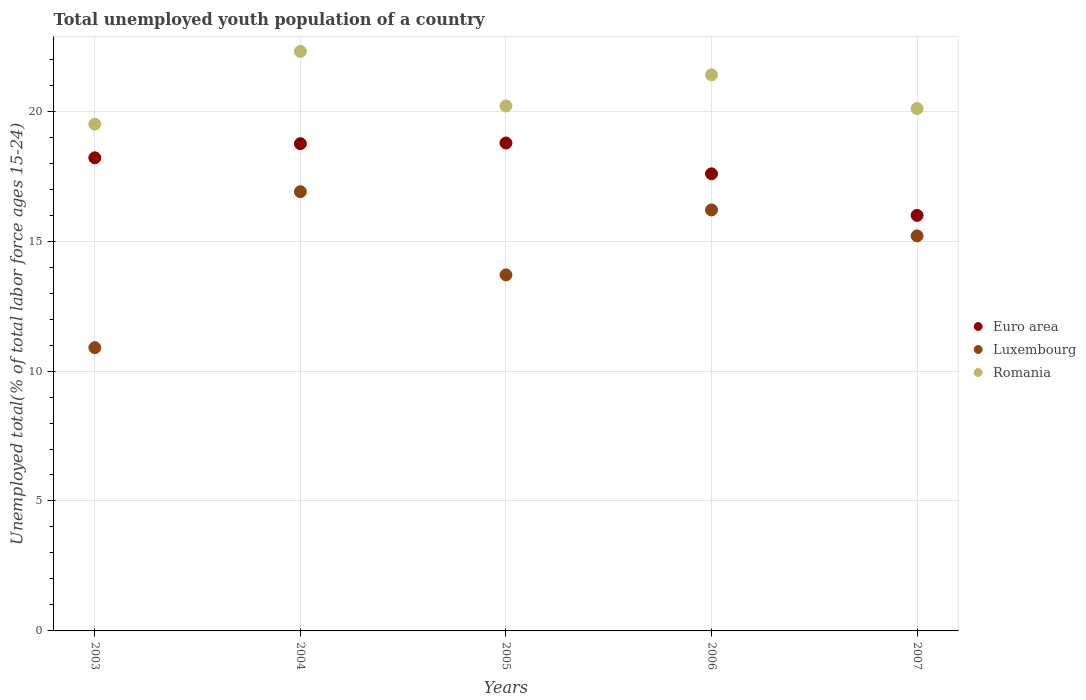What is the percentage of total unemployed youth population of a country in Luxembourg in 2005?
Keep it short and to the point. 13.7. Across all years, what is the maximum percentage of total unemployed youth population of a country in Romania?
Provide a succinct answer. 22.3. In which year was the percentage of total unemployed youth population of a country in Romania maximum?
Offer a terse response. 2004. What is the total percentage of total unemployed youth population of a country in Luxembourg in the graph?
Provide a short and direct response. 72.9. What is the difference between the percentage of total unemployed youth population of a country in Euro area in 2004 and that in 2006?
Your answer should be very brief. 1.16. What is the difference between the percentage of total unemployed youth population of a country in Euro area in 2003 and the percentage of total unemployed youth population of a country in Luxembourg in 2007?
Ensure brevity in your answer.  3. What is the average percentage of total unemployed youth population of a country in Luxembourg per year?
Ensure brevity in your answer.  14.58. In the year 2007, what is the difference between the percentage of total unemployed youth population of a country in Romania and percentage of total unemployed youth population of a country in Euro area?
Provide a succinct answer. 4.11. In how many years, is the percentage of total unemployed youth population of a country in Luxembourg greater than 20 %?
Offer a very short reply. 0. What is the ratio of the percentage of total unemployed youth population of a country in Romania in 2004 to that in 2006?
Your answer should be compact. 1.04. What is the difference between the highest and the second highest percentage of total unemployed youth population of a country in Euro area?
Ensure brevity in your answer.  0.03. What is the difference between the highest and the lowest percentage of total unemployed youth population of a country in Romania?
Your response must be concise. 2.8. In how many years, is the percentage of total unemployed youth population of a country in Romania greater than the average percentage of total unemployed youth population of a country in Romania taken over all years?
Your answer should be compact. 2. Does the percentage of total unemployed youth population of a country in Luxembourg monotonically increase over the years?
Offer a terse response. No. Is the percentage of total unemployed youth population of a country in Romania strictly greater than the percentage of total unemployed youth population of a country in Euro area over the years?
Ensure brevity in your answer.  Yes. How many dotlines are there?
Offer a terse response. 3. How many years are there in the graph?
Keep it short and to the point. 5. Are the values on the major ticks of Y-axis written in scientific E-notation?
Offer a terse response. No. Where does the legend appear in the graph?
Your answer should be very brief. Center right. How are the legend labels stacked?
Provide a short and direct response. Vertical. What is the title of the graph?
Your answer should be compact. Total unemployed youth population of a country. Does "Montenegro" appear as one of the legend labels in the graph?
Offer a terse response. No. What is the label or title of the Y-axis?
Keep it short and to the point. Unemployed total(% of total labor force ages 15-24). What is the Unemployed total(% of total labor force ages 15-24) of Euro area in 2003?
Your answer should be compact. 18.2. What is the Unemployed total(% of total labor force ages 15-24) in Luxembourg in 2003?
Your answer should be very brief. 10.9. What is the Unemployed total(% of total labor force ages 15-24) of Euro area in 2004?
Provide a succinct answer. 18.75. What is the Unemployed total(% of total labor force ages 15-24) in Luxembourg in 2004?
Your answer should be compact. 16.9. What is the Unemployed total(% of total labor force ages 15-24) of Romania in 2004?
Ensure brevity in your answer.  22.3. What is the Unemployed total(% of total labor force ages 15-24) of Euro area in 2005?
Offer a very short reply. 18.77. What is the Unemployed total(% of total labor force ages 15-24) in Luxembourg in 2005?
Keep it short and to the point. 13.7. What is the Unemployed total(% of total labor force ages 15-24) of Romania in 2005?
Your answer should be compact. 20.2. What is the Unemployed total(% of total labor force ages 15-24) in Euro area in 2006?
Offer a very short reply. 17.59. What is the Unemployed total(% of total labor force ages 15-24) in Luxembourg in 2006?
Offer a very short reply. 16.2. What is the Unemployed total(% of total labor force ages 15-24) of Romania in 2006?
Make the answer very short. 21.4. What is the Unemployed total(% of total labor force ages 15-24) in Euro area in 2007?
Offer a terse response. 15.99. What is the Unemployed total(% of total labor force ages 15-24) of Luxembourg in 2007?
Offer a terse response. 15.2. What is the Unemployed total(% of total labor force ages 15-24) of Romania in 2007?
Offer a terse response. 20.1. Across all years, what is the maximum Unemployed total(% of total labor force ages 15-24) in Euro area?
Keep it short and to the point. 18.77. Across all years, what is the maximum Unemployed total(% of total labor force ages 15-24) in Luxembourg?
Your answer should be compact. 16.9. Across all years, what is the maximum Unemployed total(% of total labor force ages 15-24) in Romania?
Keep it short and to the point. 22.3. Across all years, what is the minimum Unemployed total(% of total labor force ages 15-24) in Euro area?
Your response must be concise. 15.99. Across all years, what is the minimum Unemployed total(% of total labor force ages 15-24) of Luxembourg?
Keep it short and to the point. 10.9. Across all years, what is the minimum Unemployed total(% of total labor force ages 15-24) of Romania?
Your answer should be very brief. 19.5. What is the total Unemployed total(% of total labor force ages 15-24) of Euro area in the graph?
Your answer should be very brief. 89.31. What is the total Unemployed total(% of total labor force ages 15-24) in Luxembourg in the graph?
Ensure brevity in your answer.  72.9. What is the total Unemployed total(% of total labor force ages 15-24) of Romania in the graph?
Offer a terse response. 103.5. What is the difference between the Unemployed total(% of total labor force ages 15-24) in Euro area in 2003 and that in 2004?
Offer a very short reply. -0.54. What is the difference between the Unemployed total(% of total labor force ages 15-24) of Luxembourg in 2003 and that in 2004?
Provide a succinct answer. -6. What is the difference between the Unemployed total(% of total labor force ages 15-24) in Euro area in 2003 and that in 2005?
Your response must be concise. -0.57. What is the difference between the Unemployed total(% of total labor force ages 15-24) in Luxembourg in 2003 and that in 2005?
Keep it short and to the point. -2.8. What is the difference between the Unemployed total(% of total labor force ages 15-24) in Romania in 2003 and that in 2005?
Provide a short and direct response. -0.7. What is the difference between the Unemployed total(% of total labor force ages 15-24) in Euro area in 2003 and that in 2006?
Offer a very short reply. 0.62. What is the difference between the Unemployed total(% of total labor force ages 15-24) in Luxembourg in 2003 and that in 2006?
Make the answer very short. -5.3. What is the difference between the Unemployed total(% of total labor force ages 15-24) of Euro area in 2003 and that in 2007?
Your answer should be compact. 2.22. What is the difference between the Unemployed total(% of total labor force ages 15-24) in Luxembourg in 2003 and that in 2007?
Your answer should be compact. -4.3. What is the difference between the Unemployed total(% of total labor force ages 15-24) of Euro area in 2004 and that in 2005?
Your response must be concise. -0.03. What is the difference between the Unemployed total(% of total labor force ages 15-24) of Euro area in 2004 and that in 2006?
Provide a short and direct response. 1.16. What is the difference between the Unemployed total(% of total labor force ages 15-24) in Luxembourg in 2004 and that in 2006?
Your response must be concise. 0.7. What is the difference between the Unemployed total(% of total labor force ages 15-24) in Romania in 2004 and that in 2006?
Your answer should be compact. 0.9. What is the difference between the Unemployed total(% of total labor force ages 15-24) in Euro area in 2004 and that in 2007?
Your answer should be compact. 2.76. What is the difference between the Unemployed total(% of total labor force ages 15-24) of Romania in 2004 and that in 2007?
Give a very brief answer. 2.2. What is the difference between the Unemployed total(% of total labor force ages 15-24) in Euro area in 2005 and that in 2006?
Your answer should be compact. 1.19. What is the difference between the Unemployed total(% of total labor force ages 15-24) in Romania in 2005 and that in 2006?
Give a very brief answer. -1.2. What is the difference between the Unemployed total(% of total labor force ages 15-24) of Euro area in 2005 and that in 2007?
Keep it short and to the point. 2.79. What is the difference between the Unemployed total(% of total labor force ages 15-24) in Luxembourg in 2005 and that in 2007?
Offer a terse response. -1.5. What is the difference between the Unemployed total(% of total labor force ages 15-24) in Euro area in 2006 and that in 2007?
Offer a terse response. 1.6. What is the difference between the Unemployed total(% of total labor force ages 15-24) of Luxembourg in 2006 and that in 2007?
Your answer should be very brief. 1. What is the difference between the Unemployed total(% of total labor force ages 15-24) in Romania in 2006 and that in 2007?
Make the answer very short. 1.3. What is the difference between the Unemployed total(% of total labor force ages 15-24) in Euro area in 2003 and the Unemployed total(% of total labor force ages 15-24) in Luxembourg in 2004?
Ensure brevity in your answer.  1.3. What is the difference between the Unemployed total(% of total labor force ages 15-24) in Euro area in 2003 and the Unemployed total(% of total labor force ages 15-24) in Romania in 2004?
Ensure brevity in your answer.  -4.09. What is the difference between the Unemployed total(% of total labor force ages 15-24) in Luxembourg in 2003 and the Unemployed total(% of total labor force ages 15-24) in Romania in 2004?
Provide a short and direct response. -11.4. What is the difference between the Unemployed total(% of total labor force ages 15-24) of Euro area in 2003 and the Unemployed total(% of total labor force ages 15-24) of Luxembourg in 2005?
Give a very brief answer. 4.5. What is the difference between the Unemployed total(% of total labor force ages 15-24) in Euro area in 2003 and the Unemployed total(% of total labor force ages 15-24) in Romania in 2005?
Give a very brief answer. -2. What is the difference between the Unemployed total(% of total labor force ages 15-24) in Luxembourg in 2003 and the Unemployed total(% of total labor force ages 15-24) in Romania in 2005?
Give a very brief answer. -9.3. What is the difference between the Unemployed total(% of total labor force ages 15-24) of Euro area in 2003 and the Unemployed total(% of total labor force ages 15-24) of Luxembourg in 2006?
Your response must be concise. 2. What is the difference between the Unemployed total(% of total labor force ages 15-24) of Euro area in 2003 and the Unemployed total(% of total labor force ages 15-24) of Romania in 2006?
Provide a short and direct response. -3.19. What is the difference between the Unemployed total(% of total labor force ages 15-24) in Luxembourg in 2003 and the Unemployed total(% of total labor force ages 15-24) in Romania in 2006?
Ensure brevity in your answer.  -10.5. What is the difference between the Unemployed total(% of total labor force ages 15-24) of Euro area in 2003 and the Unemployed total(% of total labor force ages 15-24) of Luxembourg in 2007?
Keep it short and to the point. 3. What is the difference between the Unemployed total(% of total labor force ages 15-24) in Euro area in 2003 and the Unemployed total(% of total labor force ages 15-24) in Romania in 2007?
Offer a terse response. -1.9. What is the difference between the Unemployed total(% of total labor force ages 15-24) of Luxembourg in 2003 and the Unemployed total(% of total labor force ages 15-24) of Romania in 2007?
Offer a very short reply. -9.2. What is the difference between the Unemployed total(% of total labor force ages 15-24) in Euro area in 2004 and the Unemployed total(% of total labor force ages 15-24) in Luxembourg in 2005?
Give a very brief answer. 5.05. What is the difference between the Unemployed total(% of total labor force ages 15-24) in Euro area in 2004 and the Unemployed total(% of total labor force ages 15-24) in Romania in 2005?
Offer a terse response. -1.45. What is the difference between the Unemployed total(% of total labor force ages 15-24) in Euro area in 2004 and the Unemployed total(% of total labor force ages 15-24) in Luxembourg in 2006?
Keep it short and to the point. 2.55. What is the difference between the Unemployed total(% of total labor force ages 15-24) of Euro area in 2004 and the Unemployed total(% of total labor force ages 15-24) of Romania in 2006?
Make the answer very short. -2.65. What is the difference between the Unemployed total(% of total labor force ages 15-24) of Luxembourg in 2004 and the Unemployed total(% of total labor force ages 15-24) of Romania in 2006?
Your response must be concise. -4.5. What is the difference between the Unemployed total(% of total labor force ages 15-24) in Euro area in 2004 and the Unemployed total(% of total labor force ages 15-24) in Luxembourg in 2007?
Offer a terse response. 3.55. What is the difference between the Unemployed total(% of total labor force ages 15-24) of Euro area in 2004 and the Unemployed total(% of total labor force ages 15-24) of Romania in 2007?
Offer a terse response. -1.35. What is the difference between the Unemployed total(% of total labor force ages 15-24) of Euro area in 2005 and the Unemployed total(% of total labor force ages 15-24) of Luxembourg in 2006?
Provide a short and direct response. 2.58. What is the difference between the Unemployed total(% of total labor force ages 15-24) of Euro area in 2005 and the Unemployed total(% of total labor force ages 15-24) of Romania in 2006?
Ensure brevity in your answer.  -2.62. What is the difference between the Unemployed total(% of total labor force ages 15-24) in Luxembourg in 2005 and the Unemployed total(% of total labor force ages 15-24) in Romania in 2006?
Your response must be concise. -7.7. What is the difference between the Unemployed total(% of total labor force ages 15-24) in Euro area in 2005 and the Unemployed total(% of total labor force ages 15-24) in Luxembourg in 2007?
Provide a short and direct response. 3.58. What is the difference between the Unemployed total(% of total labor force ages 15-24) of Euro area in 2005 and the Unemployed total(% of total labor force ages 15-24) of Romania in 2007?
Your answer should be very brief. -1.32. What is the difference between the Unemployed total(% of total labor force ages 15-24) of Luxembourg in 2005 and the Unemployed total(% of total labor force ages 15-24) of Romania in 2007?
Offer a very short reply. -6.4. What is the difference between the Unemployed total(% of total labor force ages 15-24) of Euro area in 2006 and the Unemployed total(% of total labor force ages 15-24) of Luxembourg in 2007?
Your answer should be compact. 2.39. What is the difference between the Unemployed total(% of total labor force ages 15-24) of Euro area in 2006 and the Unemployed total(% of total labor force ages 15-24) of Romania in 2007?
Give a very brief answer. -2.51. What is the average Unemployed total(% of total labor force ages 15-24) of Euro area per year?
Ensure brevity in your answer.  17.86. What is the average Unemployed total(% of total labor force ages 15-24) in Luxembourg per year?
Provide a succinct answer. 14.58. What is the average Unemployed total(% of total labor force ages 15-24) of Romania per year?
Give a very brief answer. 20.7. In the year 2003, what is the difference between the Unemployed total(% of total labor force ages 15-24) of Euro area and Unemployed total(% of total labor force ages 15-24) of Luxembourg?
Provide a succinct answer. 7.3. In the year 2003, what is the difference between the Unemployed total(% of total labor force ages 15-24) in Euro area and Unemployed total(% of total labor force ages 15-24) in Romania?
Ensure brevity in your answer.  -1.29. In the year 2003, what is the difference between the Unemployed total(% of total labor force ages 15-24) in Luxembourg and Unemployed total(% of total labor force ages 15-24) in Romania?
Your answer should be compact. -8.6. In the year 2004, what is the difference between the Unemployed total(% of total labor force ages 15-24) in Euro area and Unemployed total(% of total labor force ages 15-24) in Luxembourg?
Give a very brief answer. 1.85. In the year 2004, what is the difference between the Unemployed total(% of total labor force ages 15-24) in Euro area and Unemployed total(% of total labor force ages 15-24) in Romania?
Give a very brief answer. -3.55. In the year 2005, what is the difference between the Unemployed total(% of total labor force ages 15-24) of Euro area and Unemployed total(% of total labor force ages 15-24) of Luxembourg?
Provide a succinct answer. 5.08. In the year 2005, what is the difference between the Unemployed total(% of total labor force ages 15-24) in Euro area and Unemployed total(% of total labor force ages 15-24) in Romania?
Give a very brief answer. -1.43. In the year 2005, what is the difference between the Unemployed total(% of total labor force ages 15-24) in Luxembourg and Unemployed total(% of total labor force ages 15-24) in Romania?
Keep it short and to the point. -6.5. In the year 2006, what is the difference between the Unemployed total(% of total labor force ages 15-24) in Euro area and Unemployed total(% of total labor force ages 15-24) in Luxembourg?
Your response must be concise. 1.39. In the year 2006, what is the difference between the Unemployed total(% of total labor force ages 15-24) in Euro area and Unemployed total(% of total labor force ages 15-24) in Romania?
Provide a short and direct response. -3.81. In the year 2007, what is the difference between the Unemployed total(% of total labor force ages 15-24) in Euro area and Unemployed total(% of total labor force ages 15-24) in Luxembourg?
Give a very brief answer. 0.79. In the year 2007, what is the difference between the Unemployed total(% of total labor force ages 15-24) in Euro area and Unemployed total(% of total labor force ages 15-24) in Romania?
Make the answer very short. -4.11. What is the ratio of the Unemployed total(% of total labor force ages 15-24) in Luxembourg in 2003 to that in 2004?
Keep it short and to the point. 0.65. What is the ratio of the Unemployed total(% of total labor force ages 15-24) in Romania in 2003 to that in 2004?
Provide a short and direct response. 0.87. What is the ratio of the Unemployed total(% of total labor force ages 15-24) in Euro area in 2003 to that in 2005?
Keep it short and to the point. 0.97. What is the ratio of the Unemployed total(% of total labor force ages 15-24) in Luxembourg in 2003 to that in 2005?
Your answer should be very brief. 0.8. What is the ratio of the Unemployed total(% of total labor force ages 15-24) in Romania in 2003 to that in 2005?
Your answer should be compact. 0.97. What is the ratio of the Unemployed total(% of total labor force ages 15-24) of Euro area in 2003 to that in 2006?
Make the answer very short. 1.03. What is the ratio of the Unemployed total(% of total labor force ages 15-24) of Luxembourg in 2003 to that in 2006?
Give a very brief answer. 0.67. What is the ratio of the Unemployed total(% of total labor force ages 15-24) of Romania in 2003 to that in 2006?
Your answer should be compact. 0.91. What is the ratio of the Unemployed total(% of total labor force ages 15-24) in Euro area in 2003 to that in 2007?
Give a very brief answer. 1.14. What is the ratio of the Unemployed total(% of total labor force ages 15-24) of Luxembourg in 2003 to that in 2007?
Make the answer very short. 0.72. What is the ratio of the Unemployed total(% of total labor force ages 15-24) of Romania in 2003 to that in 2007?
Offer a terse response. 0.97. What is the ratio of the Unemployed total(% of total labor force ages 15-24) in Luxembourg in 2004 to that in 2005?
Provide a short and direct response. 1.23. What is the ratio of the Unemployed total(% of total labor force ages 15-24) in Romania in 2004 to that in 2005?
Keep it short and to the point. 1.1. What is the ratio of the Unemployed total(% of total labor force ages 15-24) in Euro area in 2004 to that in 2006?
Offer a terse response. 1.07. What is the ratio of the Unemployed total(% of total labor force ages 15-24) in Luxembourg in 2004 to that in 2006?
Keep it short and to the point. 1.04. What is the ratio of the Unemployed total(% of total labor force ages 15-24) in Romania in 2004 to that in 2006?
Give a very brief answer. 1.04. What is the ratio of the Unemployed total(% of total labor force ages 15-24) of Euro area in 2004 to that in 2007?
Your response must be concise. 1.17. What is the ratio of the Unemployed total(% of total labor force ages 15-24) of Luxembourg in 2004 to that in 2007?
Provide a short and direct response. 1.11. What is the ratio of the Unemployed total(% of total labor force ages 15-24) of Romania in 2004 to that in 2007?
Your answer should be very brief. 1.11. What is the ratio of the Unemployed total(% of total labor force ages 15-24) in Euro area in 2005 to that in 2006?
Your answer should be very brief. 1.07. What is the ratio of the Unemployed total(% of total labor force ages 15-24) of Luxembourg in 2005 to that in 2006?
Provide a succinct answer. 0.85. What is the ratio of the Unemployed total(% of total labor force ages 15-24) in Romania in 2005 to that in 2006?
Your answer should be compact. 0.94. What is the ratio of the Unemployed total(% of total labor force ages 15-24) in Euro area in 2005 to that in 2007?
Give a very brief answer. 1.17. What is the ratio of the Unemployed total(% of total labor force ages 15-24) in Luxembourg in 2005 to that in 2007?
Ensure brevity in your answer.  0.9. What is the ratio of the Unemployed total(% of total labor force ages 15-24) of Romania in 2005 to that in 2007?
Your answer should be compact. 1. What is the ratio of the Unemployed total(% of total labor force ages 15-24) of Euro area in 2006 to that in 2007?
Ensure brevity in your answer.  1.1. What is the ratio of the Unemployed total(% of total labor force ages 15-24) in Luxembourg in 2006 to that in 2007?
Your answer should be compact. 1.07. What is the ratio of the Unemployed total(% of total labor force ages 15-24) of Romania in 2006 to that in 2007?
Your response must be concise. 1.06. What is the difference between the highest and the second highest Unemployed total(% of total labor force ages 15-24) of Euro area?
Your answer should be very brief. 0.03. What is the difference between the highest and the second highest Unemployed total(% of total labor force ages 15-24) of Luxembourg?
Ensure brevity in your answer.  0.7. What is the difference between the highest and the lowest Unemployed total(% of total labor force ages 15-24) of Euro area?
Provide a succinct answer. 2.79. 